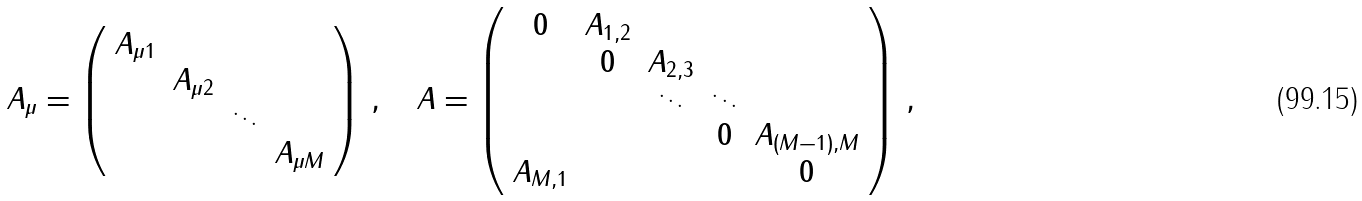<formula> <loc_0><loc_0><loc_500><loc_500>A _ { \mu } = \left ( \begin{array} { c c c c } A _ { \mu 1 } & & & \\ & A _ { \mu 2 } & & \\ & & \ddots & \\ & & & A _ { \mu M } \end{array} \right ) \, , \quad A = \left ( \begin{array} { c c c c c } 0 & A _ { 1 , 2 } & & & \\ & 0 & A _ { 2 , 3 } & & \\ & & \ddots & \ddots & \\ & & & 0 & A _ { ( M - 1 ) , M } \\ A _ { M , 1 } & & & & 0 \end{array} \right ) \, ,</formula> 